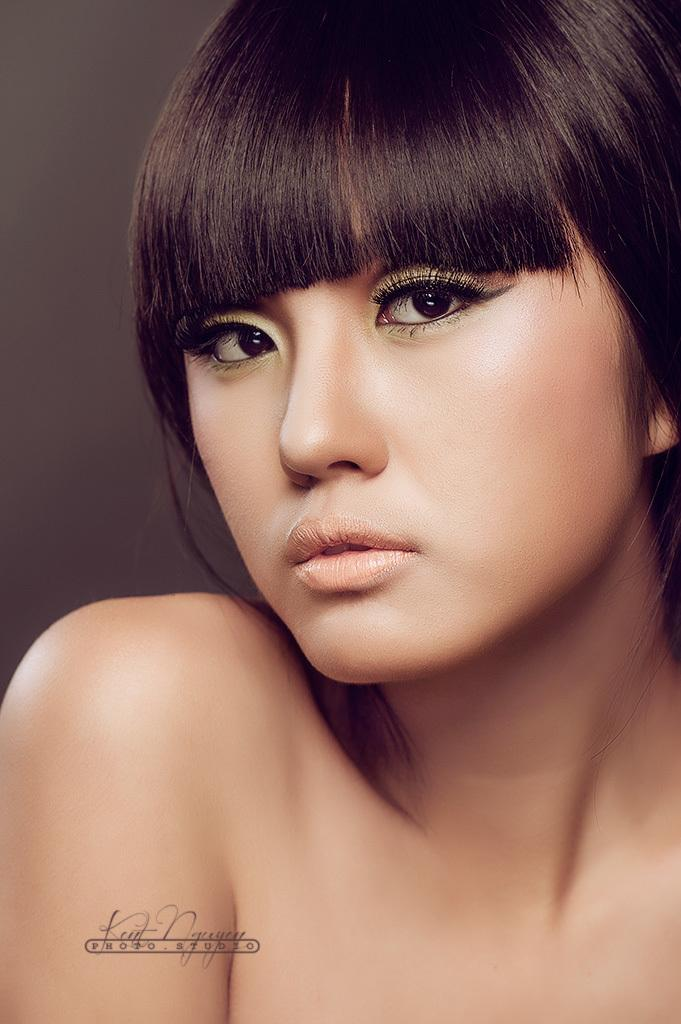Who is the main subject in the image? There is a woman in the image. What is the woman doing in the image? The woman is posing for a photo. What type of wheel can be seen in the image? There is no wheel present in the image; it features a woman posing for a photo. What kind of apparatus is the woman using to take the photo? The image does not show any apparatus or equipment being used to take the photo, as it only shows the woman posing. 